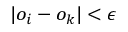Convert formula to latex. <formula><loc_0><loc_0><loc_500><loc_500>| o _ { i } - o _ { k } | < \epsilon</formula> 